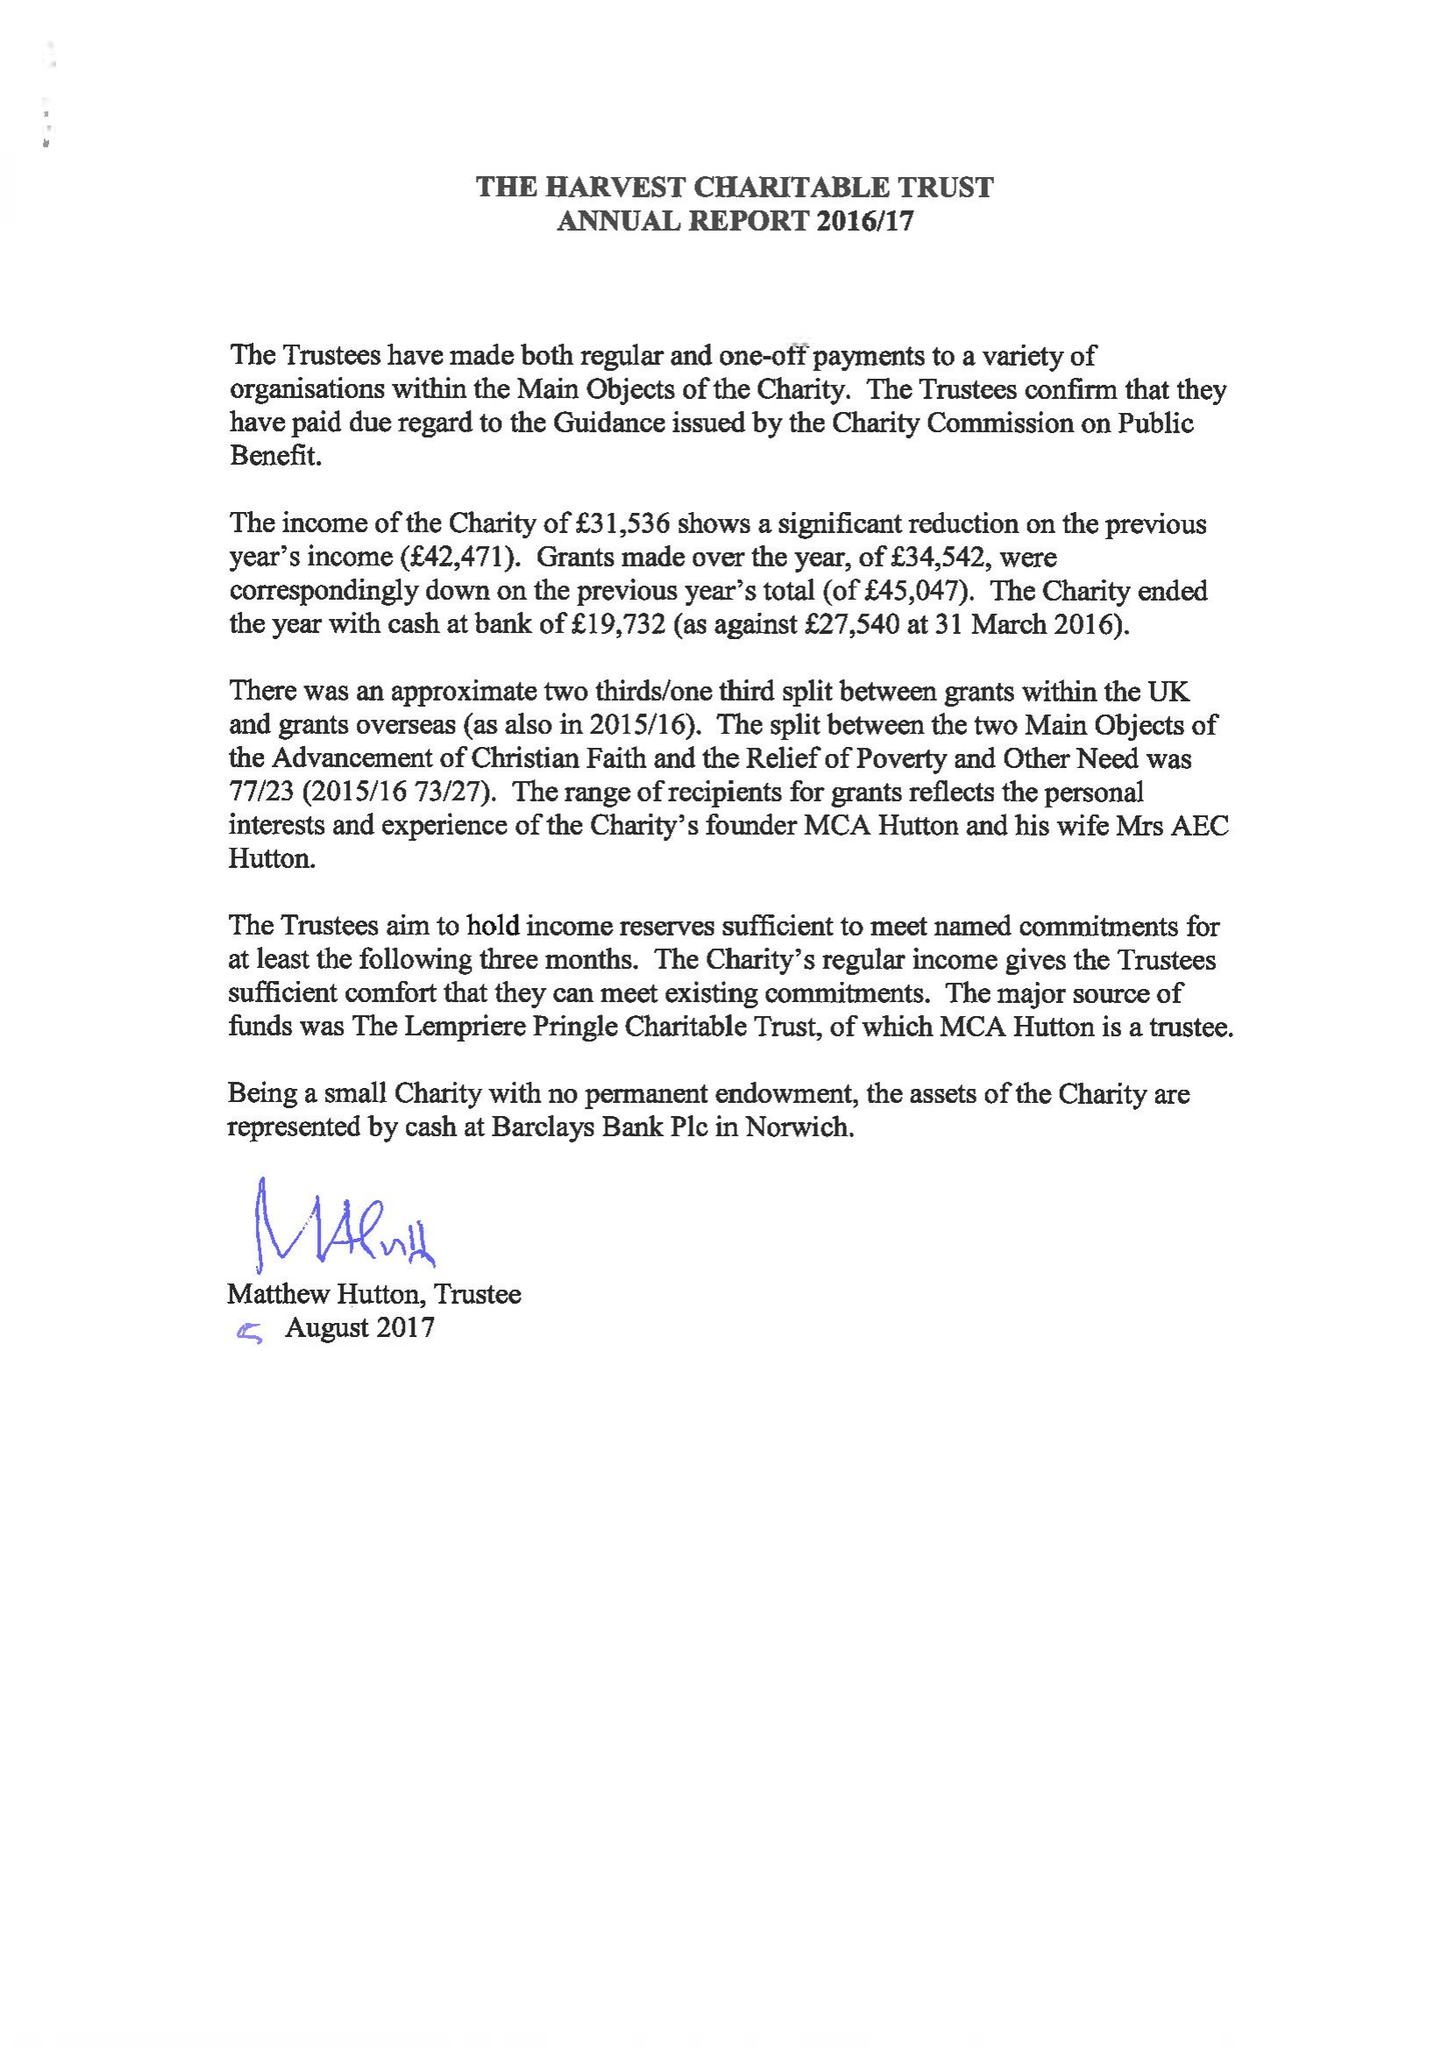What is the value for the address__street_line?
Answer the question using a single word or phrase. NORWICH ROAD 